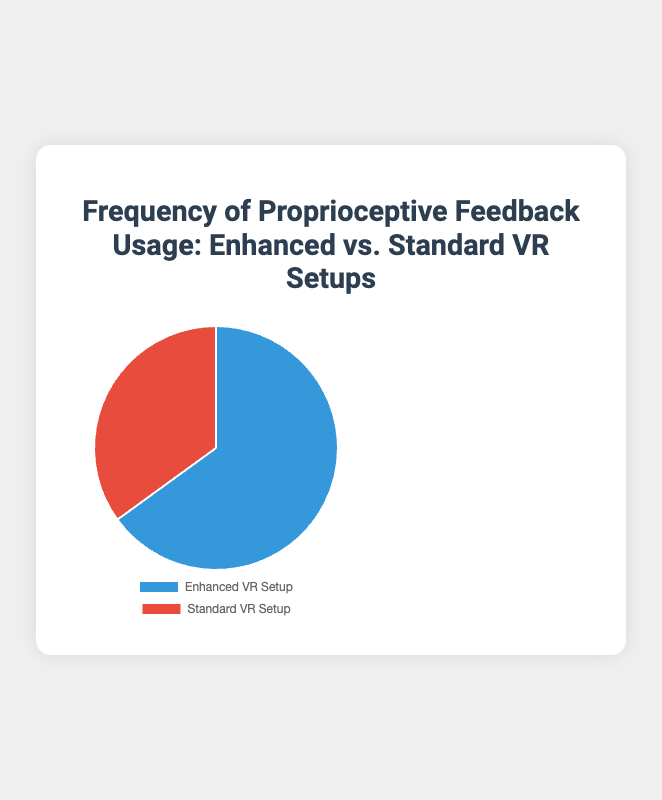Which VR setup has a higher frequency of proprioceptive feedback usage? According to the pie chart, the "Enhanced VR Setup" has a higher percentage (65%) compared to the "Standard VR Setup" (35%).
Answer: Enhanced VR Setup What's the percentage difference in proprioceptive feedback usage between Enhanced and Standard VR setups? The difference can be found by subtracting the percentage of the "Standard VR Setup" from the percentage of the "Enhanced VR Setup", which is 65% - 35%.
Answer: 30% How many times more frequent is proprioceptive feedback usage in the Enhanced VR than in the Standard VR? The frequency of proprioceptive feedback usage in the "Enhanced VR Setup" is 65%, and in the "Standard VR Setup" it is 35%. To find how many times more frequent it is, divide 65 by 35 (65% / 35%).
Answer: 1.86 What is the combined percentage of proprioceptive feedback usage across both VR setups? The combined percentage is the sum of the percentages of both "Enhanced VR Setup" and "Standard VR Setup", which is 65% + 35%.
Answer: 100% If the "Enhanced VR Setup" were represented in blue, what color represents the "Standard VR Setup"? According to the pie chart description, the "Enhanced VR Setup" is represented by the color blue, and the "Standard VR Setup" is represented by the color red.
Answer: Red 